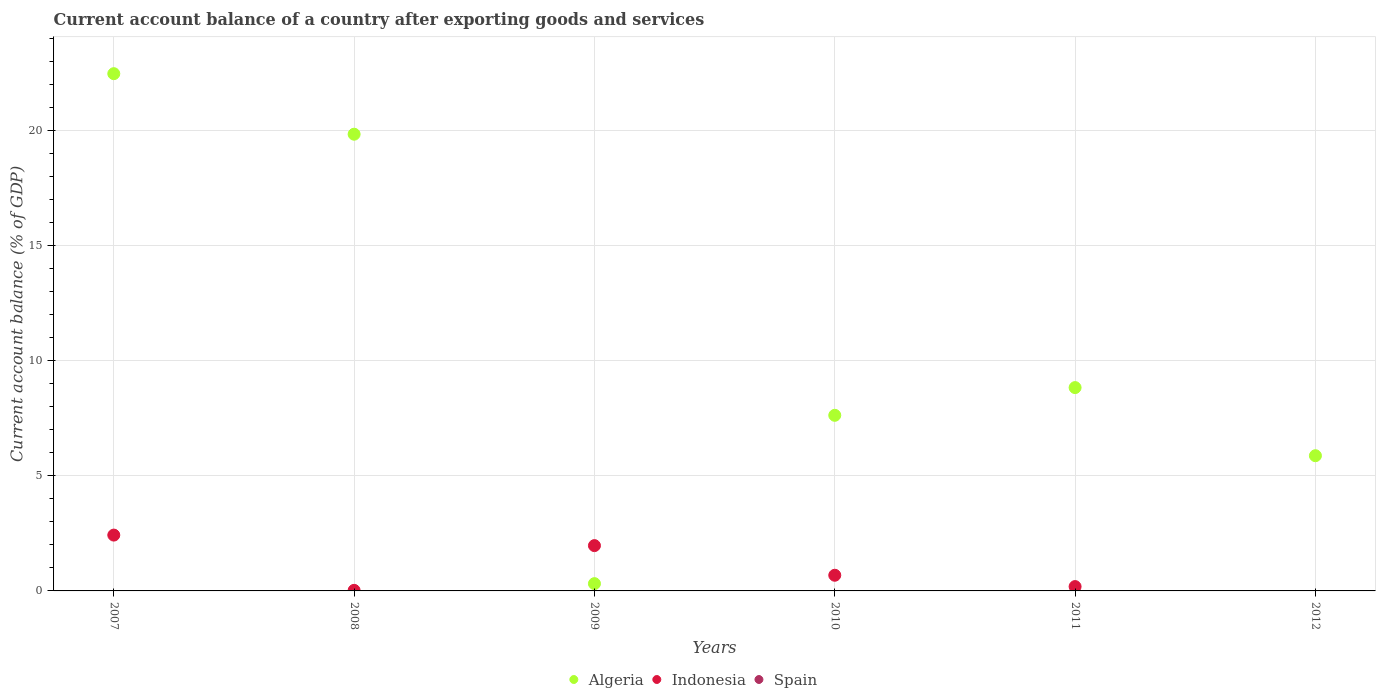How many different coloured dotlines are there?
Make the answer very short. 2. What is the account balance in Indonesia in 2011?
Offer a terse response. 0.19. Across all years, what is the maximum account balance in Indonesia?
Make the answer very short. 2.43. In which year was the account balance in Algeria maximum?
Your answer should be very brief. 2007. What is the total account balance in Algeria in the graph?
Provide a succinct answer. 65.01. What is the difference between the account balance in Algeria in 2007 and that in 2010?
Keep it short and to the point. 14.85. What is the difference between the account balance in Indonesia in 2008 and the account balance in Algeria in 2007?
Offer a terse response. -22.46. What is the average account balance in Algeria per year?
Give a very brief answer. 10.84. In the year 2009, what is the difference between the account balance in Indonesia and account balance in Algeria?
Your response must be concise. 1.65. What is the ratio of the account balance in Indonesia in 2009 to that in 2011?
Keep it short and to the point. 10.44. Is the account balance in Indonesia in 2008 less than that in 2010?
Make the answer very short. Yes. What is the difference between the highest and the second highest account balance in Indonesia?
Provide a short and direct response. 0.46. What is the difference between the highest and the lowest account balance in Indonesia?
Ensure brevity in your answer.  2.43. In how many years, is the account balance in Algeria greater than the average account balance in Algeria taken over all years?
Provide a succinct answer. 2. Is it the case that in every year, the sum of the account balance in Algeria and account balance in Spain  is greater than the account balance in Indonesia?
Ensure brevity in your answer.  No. Is the account balance in Indonesia strictly greater than the account balance in Algeria over the years?
Your answer should be very brief. No. How many dotlines are there?
Offer a very short reply. 2. What is the difference between two consecutive major ticks on the Y-axis?
Offer a very short reply. 5. Are the values on the major ticks of Y-axis written in scientific E-notation?
Provide a succinct answer. No. What is the title of the graph?
Your response must be concise. Current account balance of a country after exporting goods and services. What is the label or title of the X-axis?
Provide a short and direct response. Years. What is the label or title of the Y-axis?
Give a very brief answer. Current account balance (% of GDP). What is the Current account balance (% of GDP) of Algeria in 2007?
Provide a succinct answer. 22.49. What is the Current account balance (% of GDP) in Indonesia in 2007?
Your answer should be compact. 2.43. What is the Current account balance (% of GDP) of Algeria in 2008?
Offer a terse response. 19.86. What is the Current account balance (% of GDP) in Indonesia in 2008?
Your answer should be compact. 0.02. What is the Current account balance (% of GDP) of Algeria in 2009?
Your answer should be compact. 0.32. What is the Current account balance (% of GDP) of Indonesia in 2009?
Your response must be concise. 1.97. What is the Current account balance (% of GDP) of Algeria in 2010?
Ensure brevity in your answer.  7.64. What is the Current account balance (% of GDP) in Indonesia in 2010?
Ensure brevity in your answer.  0.68. What is the Current account balance (% of GDP) of Spain in 2010?
Offer a very short reply. 0. What is the Current account balance (% of GDP) in Algeria in 2011?
Your response must be concise. 8.84. What is the Current account balance (% of GDP) in Indonesia in 2011?
Provide a succinct answer. 0.19. What is the Current account balance (% of GDP) of Spain in 2011?
Ensure brevity in your answer.  0. What is the Current account balance (% of GDP) in Algeria in 2012?
Your answer should be compact. 5.88. What is the Current account balance (% of GDP) of Indonesia in 2012?
Your answer should be very brief. 0. What is the Current account balance (% of GDP) of Spain in 2012?
Your answer should be compact. 0. Across all years, what is the maximum Current account balance (% of GDP) in Algeria?
Provide a succinct answer. 22.49. Across all years, what is the maximum Current account balance (% of GDP) in Indonesia?
Offer a very short reply. 2.43. Across all years, what is the minimum Current account balance (% of GDP) in Algeria?
Give a very brief answer. 0.32. Across all years, what is the minimum Current account balance (% of GDP) in Indonesia?
Give a very brief answer. 0. What is the total Current account balance (% of GDP) in Algeria in the graph?
Your response must be concise. 65.01. What is the total Current account balance (% of GDP) in Indonesia in the graph?
Give a very brief answer. 5.29. What is the difference between the Current account balance (% of GDP) in Algeria in 2007 and that in 2008?
Provide a short and direct response. 2.63. What is the difference between the Current account balance (% of GDP) in Indonesia in 2007 and that in 2008?
Your answer should be compact. 2.4. What is the difference between the Current account balance (% of GDP) of Algeria in 2007 and that in 2009?
Give a very brief answer. 22.17. What is the difference between the Current account balance (% of GDP) of Indonesia in 2007 and that in 2009?
Keep it short and to the point. 0.46. What is the difference between the Current account balance (% of GDP) in Algeria in 2007 and that in 2010?
Provide a short and direct response. 14.85. What is the difference between the Current account balance (% of GDP) of Indonesia in 2007 and that in 2010?
Offer a terse response. 1.75. What is the difference between the Current account balance (% of GDP) in Algeria in 2007 and that in 2011?
Your answer should be compact. 13.65. What is the difference between the Current account balance (% of GDP) of Indonesia in 2007 and that in 2011?
Offer a terse response. 2.24. What is the difference between the Current account balance (% of GDP) in Algeria in 2007 and that in 2012?
Offer a terse response. 16.61. What is the difference between the Current account balance (% of GDP) of Algeria in 2008 and that in 2009?
Keep it short and to the point. 19.54. What is the difference between the Current account balance (% of GDP) in Indonesia in 2008 and that in 2009?
Make the answer very short. -1.95. What is the difference between the Current account balance (% of GDP) in Algeria in 2008 and that in 2010?
Your answer should be very brief. 12.22. What is the difference between the Current account balance (% of GDP) in Indonesia in 2008 and that in 2010?
Give a very brief answer. -0.66. What is the difference between the Current account balance (% of GDP) in Algeria in 2008 and that in 2011?
Your response must be concise. 11.02. What is the difference between the Current account balance (% of GDP) in Indonesia in 2008 and that in 2011?
Your answer should be compact. -0.16. What is the difference between the Current account balance (% of GDP) in Algeria in 2008 and that in 2012?
Keep it short and to the point. 13.98. What is the difference between the Current account balance (% of GDP) of Algeria in 2009 and that in 2010?
Your answer should be compact. -7.32. What is the difference between the Current account balance (% of GDP) of Indonesia in 2009 and that in 2010?
Give a very brief answer. 1.29. What is the difference between the Current account balance (% of GDP) of Algeria in 2009 and that in 2011?
Keep it short and to the point. -8.52. What is the difference between the Current account balance (% of GDP) of Indonesia in 2009 and that in 2011?
Provide a short and direct response. 1.78. What is the difference between the Current account balance (% of GDP) in Algeria in 2009 and that in 2012?
Offer a very short reply. -5.56. What is the difference between the Current account balance (% of GDP) in Algeria in 2010 and that in 2011?
Provide a short and direct response. -1.2. What is the difference between the Current account balance (% of GDP) of Indonesia in 2010 and that in 2011?
Ensure brevity in your answer.  0.49. What is the difference between the Current account balance (% of GDP) in Algeria in 2010 and that in 2012?
Provide a short and direct response. 1.76. What is the difference between the Current account balance (% of GDP) in Algeria in 2011 and that in 2012?
Offer a terse response. 2.96. What is the difference between the Current account balance (% of GDP) of Algeria in 2007 and the Current account balance (% of GDP) of Indonesia in 2008?
Your response must be concise. 22.46. What is the difference between the Current account balance (% of GDP) of Algeria in 2007 and the Current account balance (% of GDP) of Indonesia in 2009?
Keep it short and to the point. 20.52. What is the difference between the Current account balance (% of GDP) in Algeria in 2007 and the Current account balance (% of GDP) in Indonesia in 2010?
Your response must be concise. 21.81. What is the difference between the Current account balance (% of GDP) in Algeria in 2007 and the Current account balance (% of GDP) in Indonesia in 2011?
Offer a terse response. 22.3. What is the difference between the Current account balance (% of GDP) of Algeria in 2008 and the Current account balance (% of GDP) of Indonesia in 2009?
Your answer should be compact. 17.89. What is the difference between the Current account balance (% of GDP) of Algeria in 2008 and the Current account balance (% of GDP) of Indonesia in 2010?
Provide a succinct answer. 19.18. What is the difference between the Current account balance (% of GDP) in Algeria in 2008 and the Current account balance (% of GDP) in Indonesia in 2011?
Offer a very short reply. 19.67. What is the difference between the Current account balance (% of GDP) of Algeria in 2009 and the Current account balance (% of GDP) of Indonesia in 2010?
Make the answer very short. -0.36. What is the difference between the Current account balance (% of GDP) of Algeria in 2009 and the Current account balance (% of GDP) of Indonesia in 2011?
Your response must be concise. 0.13. What is the difference between the Current account balance (% of GDP) in Algeria in 2010 and the Current account balance (% of GDP) in Indonesia in 2011?
Make the answer very short. 7.45. What is the average Current account balance (% of GDP) of Algeria per year?
Provide a short and direct response. 10.84. What is the average Current account balance (% of GDP) in Indonesia per year?
Your answer should be compact. 0.88. What is the average Current account balance (% of GDP) of Spain per year?
Make the answer very short. 0. In the year 2007, what is the difference between the Current account balance (% of GDP) in Algeria and Current account balance (% of GDP) in Indonesia?
Your answer should be very brief. 20.06. In the year 2008, what is the difference between the Current account balance (% of GDP) in Algeria and Current account balance (% of GDP) in Indonesia?
Your answer should be compact. 19.83. In the year 2009, what is the difference between the Current account balance (% of GDP) of Algeria and Current account balance (% of GDP) of Indonesia?
Your answer should be very brief. -1.65. In the year 2010, what is the difference between the Current account balance (% of GDP) in Algeria and Current account balance (% of GDP) in Indonesia?
Your answer should be very brief. 6.95. In the year 2011, what is the difference between the Current account balance (% of GDP) of Algeria and Current account balance (% of GDP) of Indonesia?
Keep it short and to the point. 8.65. What is the ratio of the Current account balance (% of GDP) of Algeria in 2007 to that in 2008?
Your answer should be very brief. 1.13. What is the ratio of the Current account balance (% of GDP) of Indonesia in 2007 to that in 2008?
Provide a short and direct response. 98.3. What is the ratio of the Current account balance (% of GDP) in Algeria in 2007 to that in 2009?
Give a very brief answer. 71.1. What is the ratio of the Current account balance (% of GDP) in Indonesia in 2007 to that in 2009?
Keep it short and to the point. 1.23. What is the ratio of the Current account balance (% of GDP) of Algeria in 2007 to that in 2010?
Your answer should be compact. 2.95. What is the ratio of the Current account balance (% of GDP) in Indonesia in 2007 to that in 2010?
Make the answer very short. 3.56. What is the ratio of the Current account balance (% of GDP) of Algeria in 2007 to that in 2011?
Your response must be concise. 2.54. What is the ratio of the Current account balance (% of GDP) of Indonesia in 2007 to that in 2011?
Make the answer very short. 12.86. What is the ratio of the Current account balance (% of GDP) of Algeria in 2007 to that in 2012?
Keep it short and to the point. 3.83. What is the ratio of the Current account balance (% of GDP) of Algeria in 2008 to that in 2009?
Provide a succinct answer. 62.78. What is the ratio of the Current account balance (% of GDP) of Indonesia in 2008 to that in 2009?
Offer a very short reply. 0.01. What is the ratio of the Current account balance (% of GDP) in Algeria in 2008 to that in 2010?
Ensure brevity in your answer.  2.6. What is the ratio of the Current account balance (% of GDP) in Indonesia in 2008 to that in 2010?
Offer a terse response. 0.04. What is the ratio of the Current account balance (% of GDP) of Algeria in 2008 to that in 2011?
Your answer should be compact. 2.25. What is the ratio of the Current account balance (% of GDP) of Indonesia in 2008 to that in 2011?
Give a very brief answer. 0.13. What is the ratio of the Current account balance (% of GDP) of Algeria in 2008 to that in 2012?
Provide a short and direct response. 3.38. What is the ratio of the Current account balance (% of GDP) in Algeria in 2009 to that in 2010?
Offer a very short reply. 0.04. What is the ratio of the Current account balance (% of GDP) of Indonesia in 2009 to that in 2010?
Your response must be concise. 2.89. What is the ratio of the Current account balance (% of GDP) in Algeria in 2009 to that in 2011?
Provide a succinct answer. 0.04. What is the ratio of the Current account balance (% of GDP) in Indonesia in 2009 to that in 2011?
Offer a terse response. 10.44. What is the ratio of the Current account balance (% of GDP) in Algeria in 2009 to that in 2012?
Your response must be concise. 0.05. What is the ratio of the Current account balance (% of GDP) in Algeria in 2010 to that in 2011?
Offer a very short reply. 0.86. What is the ratio of the Current account balance (% of GDP) in Indonesia in 2010 to that in 2011?
Make the answer very short. 3.61. What is the ratio of the Current account balance (% of GDP) of Algeria in 2010 to that in 2012?
Provide a succinct answer. 1.3. What is the ratio of the Current account balance (% of GDP) of Algeria in 2011 to that in 2012?
Give a very brief answer. 1.5. What is the difference between the highest and the second highest Current account balance (% of GDP) of Algeria?
Offer a terse response. 2.63. What is the difference between the highest and the second highest Current account balance (% of GDP) in Indonesia?
Offer a very short reply. 0.46. What is the difference between the highest and the lowest Current account balance (% of GDP) of Algeria?
Offer a very short reply. 22.17. What is the difference between the highest and the lowest Current account balance (% of GDP) of Indonesia?
Provide a short and direct response. 2.43. 